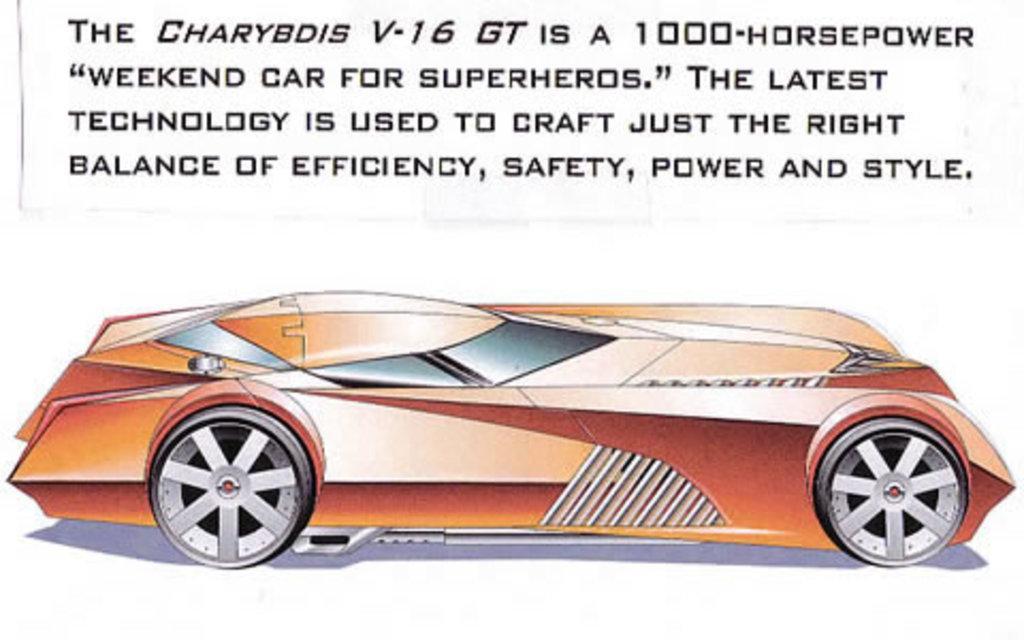Can you describe this image briefly? In this picture I can see a poster and I can see text at the top of the picture and I can see a cartoon picture of a car. 